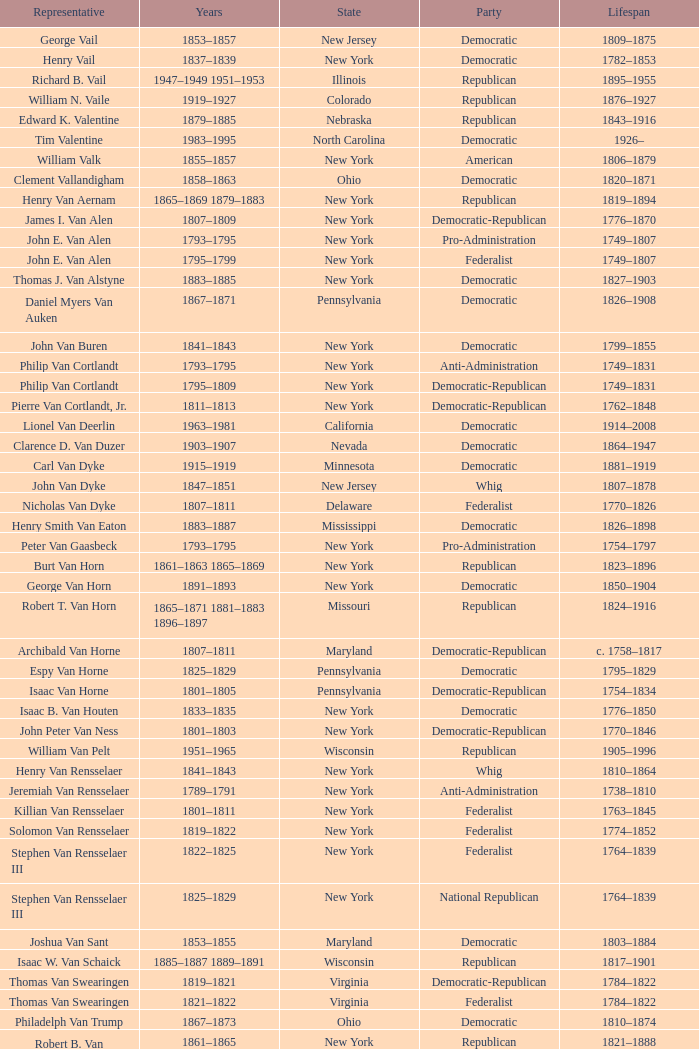What was the length of life for joseph vance, an ohio democratic-republican? 1786–1852. 